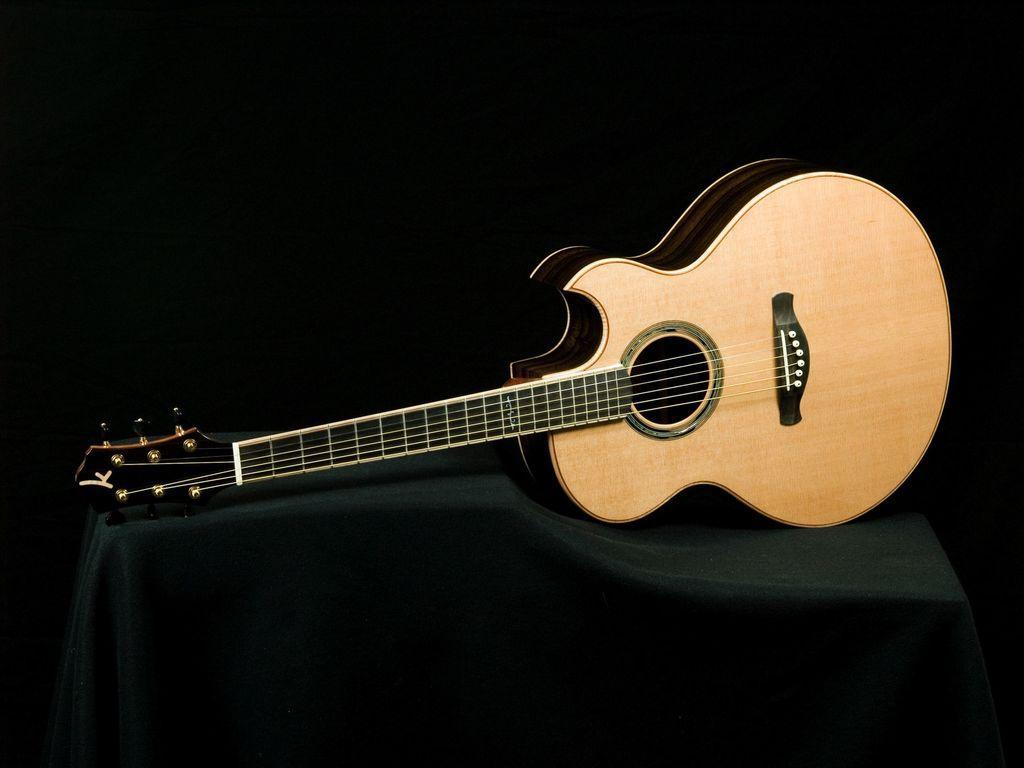Describe this image in one or two sentences. On the table with a cloth there is a guitar on it. 